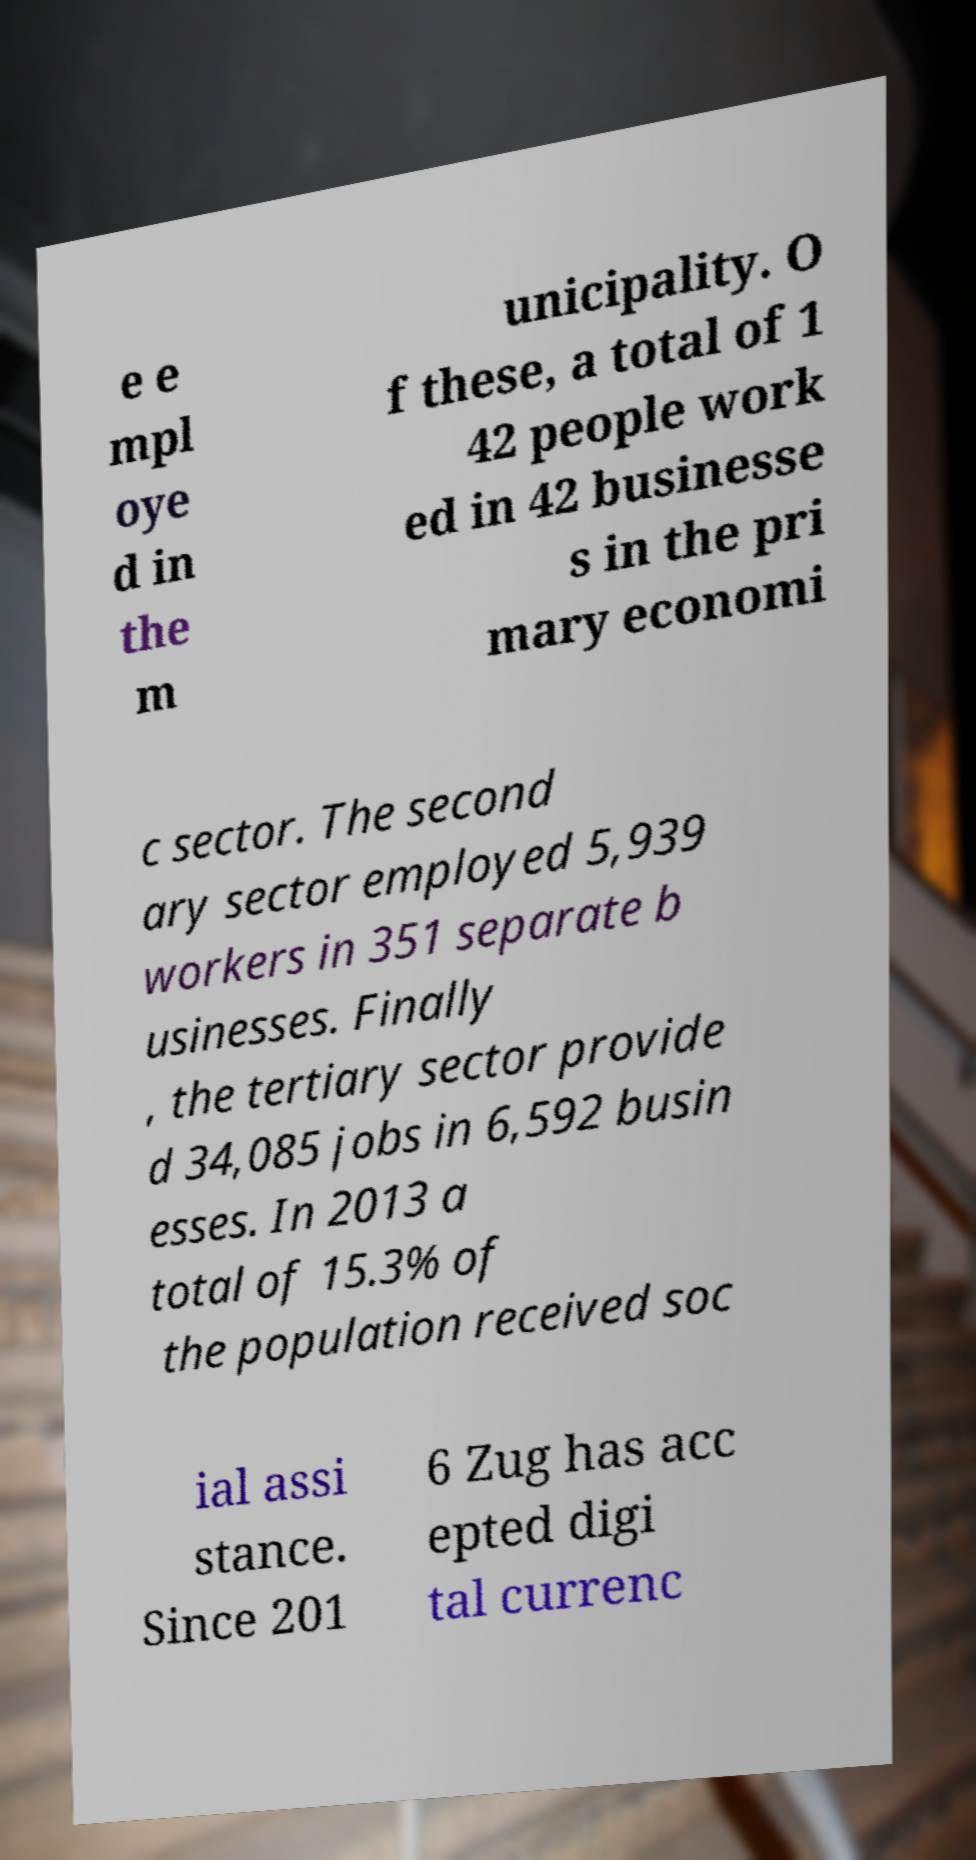Please identify and transcribe the text found in this image. e e mpl oye d in the m unicipality. O f these, a total of 1 42 people work ed in 42 businesse s in the pri mary economi c sector. The second ary sector employed 5,939 workers in 351 separate b usinesses. Finally , the tertiary sector provide d 34,085 jobs in 6,592 busin esses. In 2013 a total of 15.3% of the population received soc ial assi stance. Since 201 6 Zug has acc epted digi tal currenc 